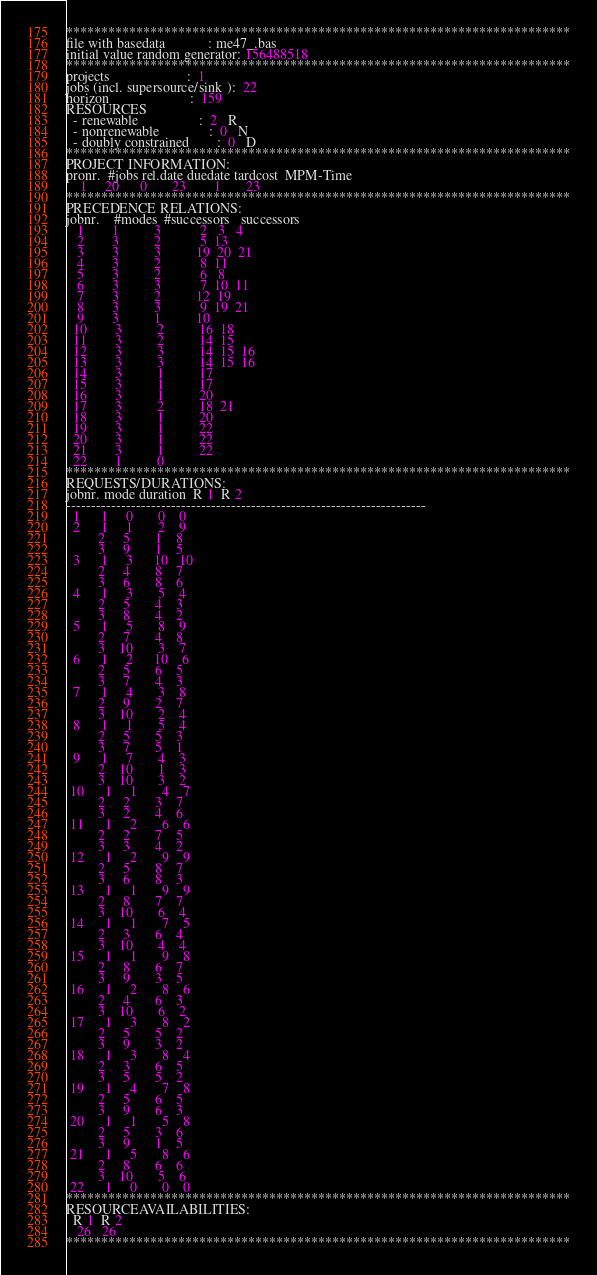<code> <loc_0><loc_0><loc_500><loc_500><_ObjectiveC_>************************************************************************
file with basedata            : me47_.bas
initial value random generator: 156488518
************************************************************************
projects                      :  1
jobs (incl. supersource/sink ):  22
horizon                       :  159
RESOURCES
  - renewable                 :  2   R
  - nonrenewable              :  0   N
  - doubly constrained        :  0   D
************************************************************************
PROJECT INFORMATION:
pronr.  #jobs rel.date duedate tardcost  MPM-Time
    1     20      0       23        1       23
************************************************************************
PRECEDENCE RELATIONS:
jobnr.    #modes  #successors   successors
   1        1          3           2   3   4
   2        3          2           5  13
   3        3          3          19  20  21
   4        3          2           8  11
   5        3          2           6   8
   6        3          3           7  10  11
   7        3          2          12  19
   8        3          3           9  19  21
   9        3          1          10
  10        3          2          16  18
  11        3          2          14  15
  12        3          3          14  15  16
  13        3          3          14  15  16
  14        3          1          17
  15        3          1          17
  16        3          1          20
  17        3          2          18  21
  18        3          1          20
  19        3          1          22
  20        3          1          22
  21        3          1          22
  22        1          0        
************************************************************************
REQUESTS/DURATIONS:
jobnr. mode duration  R 1  R 2
------------------------------------------------------------------------
  1      1     0       0    0
  2      1     1       2    9
         2     5       1    8
         3     9       1    5
  3      1     3      10   10
         2     4       8    7
         3     6       8    6
  4      1     3       5    4
         2     5       4    3
         3     8       4    2
  5      1     5       8    9
         2     7       4    8
         3    10       3    7
  6      1     2      10    6
         2     5       6    5
         3     7       4    3
  7      1     4       3    8
         2     9       2    7
         3    10       2    4
  8      1     1       5    4
         2     5       5    3
         3     7       5    1
  9      1     7       4    3
         2    10       1    3
         3    10       3    2
 10      1     1       4    7
         2     2       3    7
         3     2       4    6
 11      1     2       6    6
         2     2       7    5
         3     3       4    2
 12      1     2       9    9
         2     5       8    7
         3     6       8    3
 13      1     1       9    9
         2     8       7    7
         3    10       6    4
 14      1     1       7    5
         2     3       6    4
         3    10       4    4
 15      1     1       9    8
         2     8       6    7
         3     9       3    5
 16      1     2       8    6
         2     4       6    3
         3    10       6    2
 17      1     3       8    2
         2     5       5    2
         3     9       3    2
 18      1     3       8    4
         2     3       6    5
         3     5       5    2
 19      1     4       7    8
         2     5       6    5
         3     9       6    3
 20      1     1       5    8
         2     5       3    6
         3     9       1    5
 21      1     5       8    6
         2     8       6    6
         3    10       5    6
 22      1     0       0    0
************************************************************************
RESOURCEAVAILABILITIES:
  R 1  R 2
   26   26
************************************************************************
</code> 